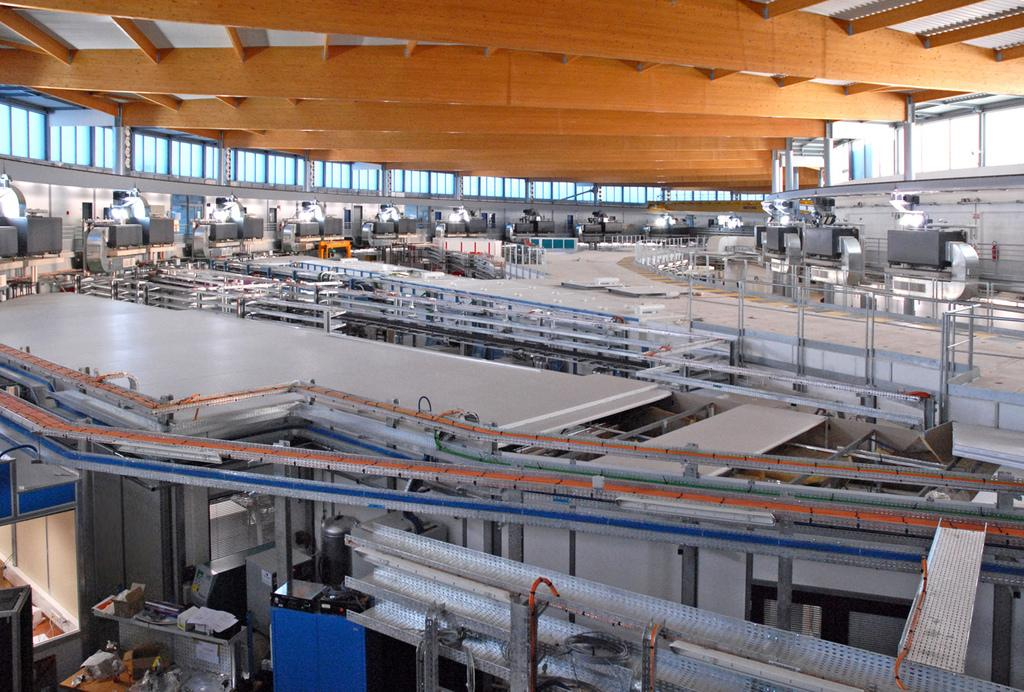What type of location is depicted in the image? The image appears to depict a factory. What can be seen in the foreground of the image? There are machines in the foreground of the image. What is visible at the top of the image? There is a roof visible at the top of the image. Where are the windows located in the image? There are windows on the left and right corners of the image. How many airplanes are parked on the roof of the factory in the image? There are no airplanes visible on the roof of the factory in the image. What type of pail is used to collect materials from the machines in the image? There is no pail present in the image; the focus is on the machines and the factory setting. 